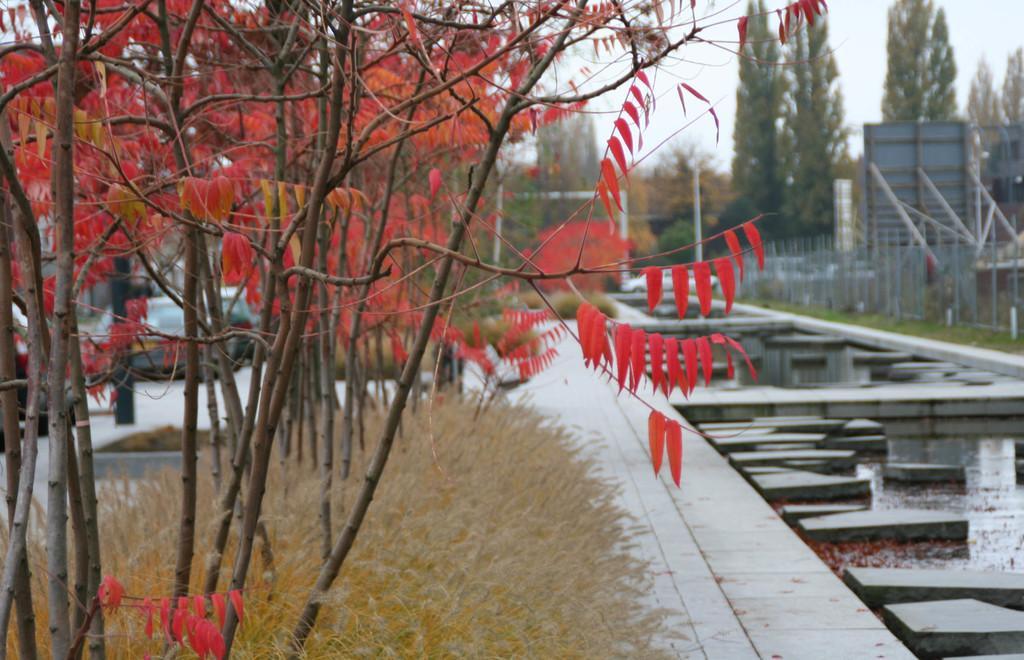How would you summarize this image in a sentence or two? In this image we can see some trees, fence, water and other objects. In the background of the image there are trees, vehicles and the sky. At the bottom of the image there is the grass and a walkway. 